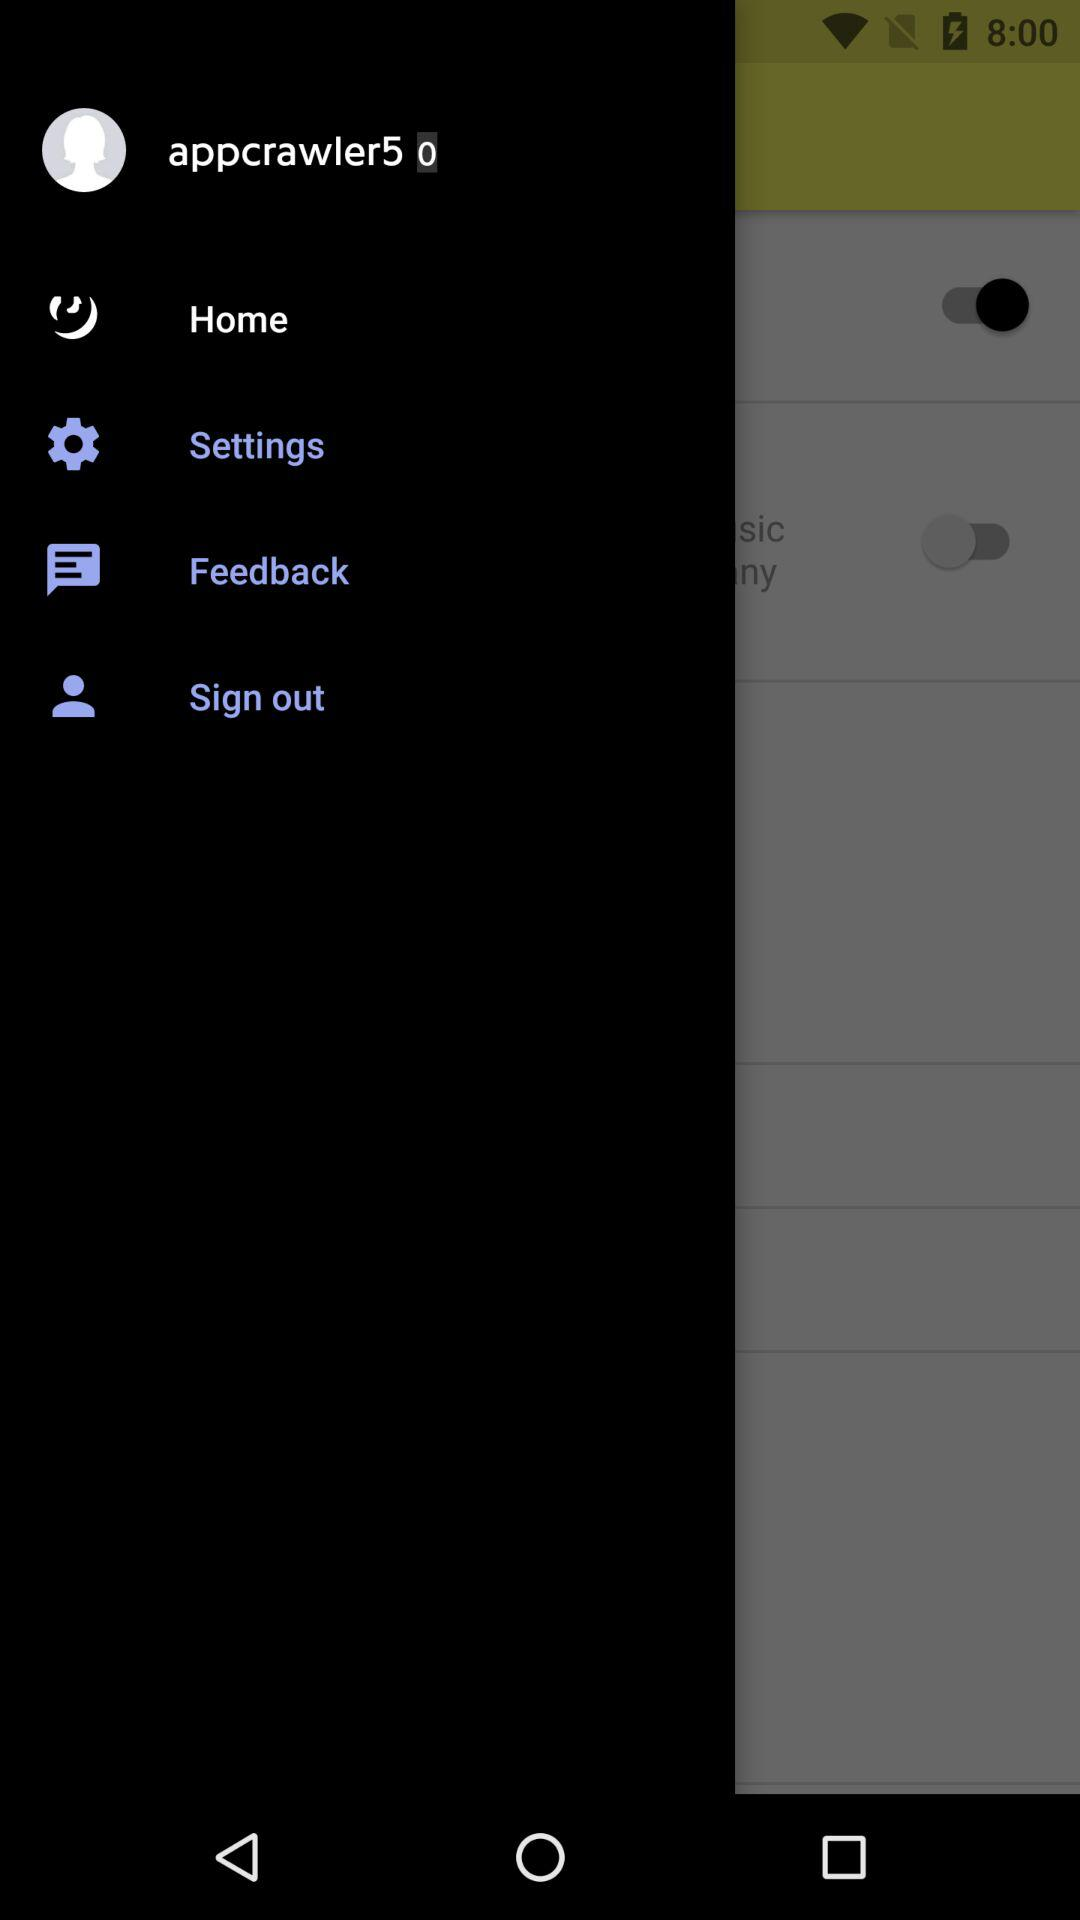What is the username? The username is "appcrawler5". 